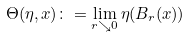<formula> <loc_0><loc_0><loc_500><loc_500>\Theta ( \eta , x ) \colon = \lim _ { r \searrow 0 } \eta ( B _ { r } ( x ) )</formula> 